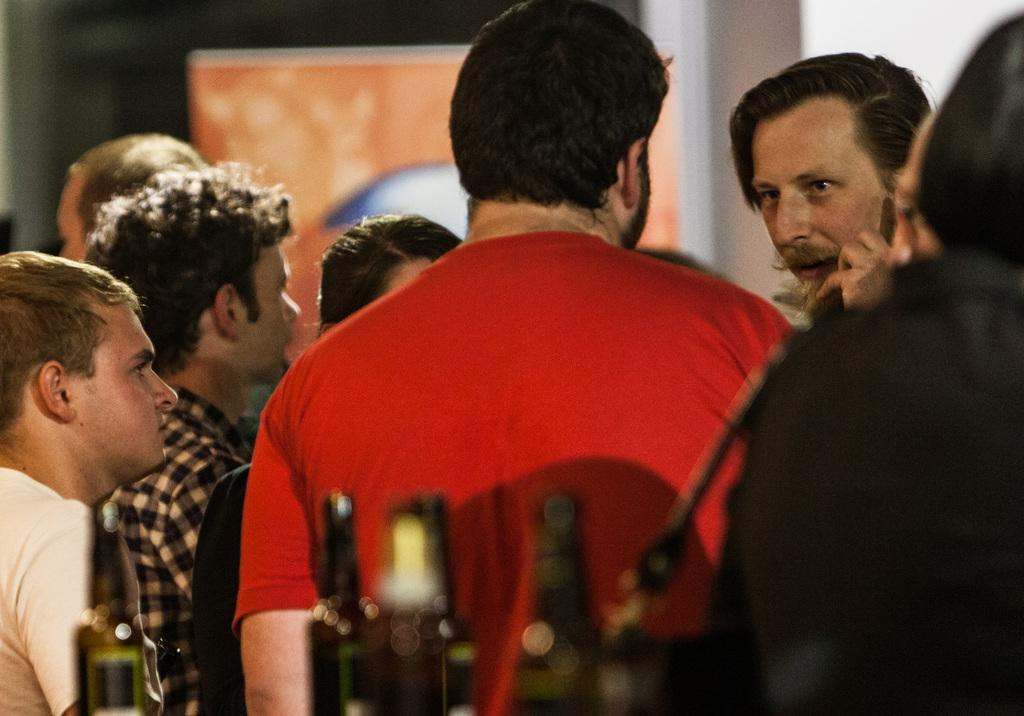What is happening in the image? There is a group of people standing in the image. What objects can be seen at the bottom of the image? There are bottles at the bottom of the image. What can be seen in the background of the image? There is a poster in the background of the image. How many jellyfish are swimming in the image? There are no jellyfish present in the image. What type of collar is being worn by the people in the image? The image does not show any collars being worn by the people. 